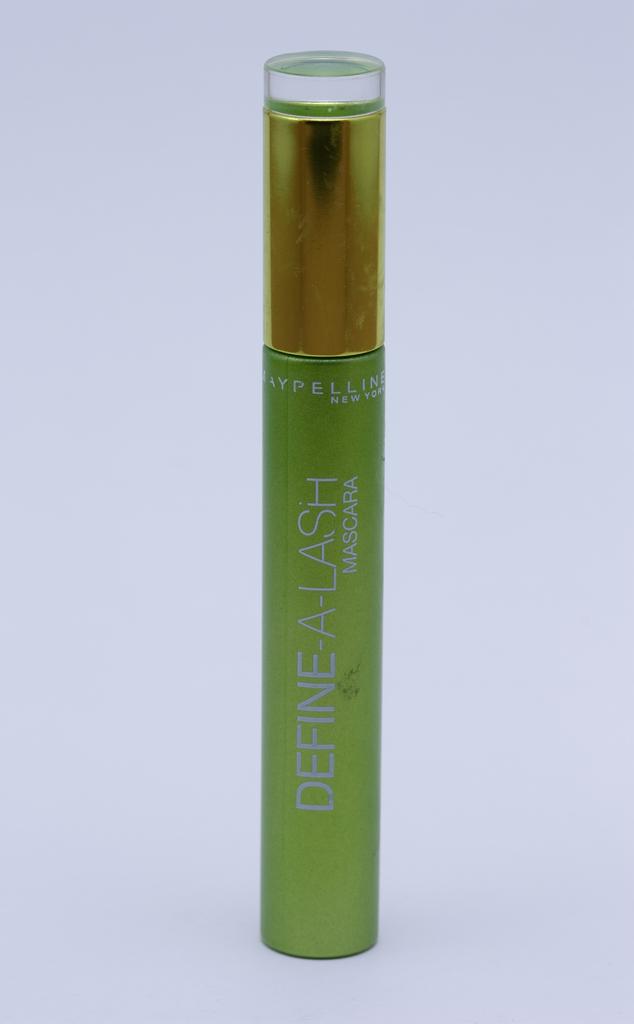Was this made in new york?
Provide a short and direct response. Yes. 